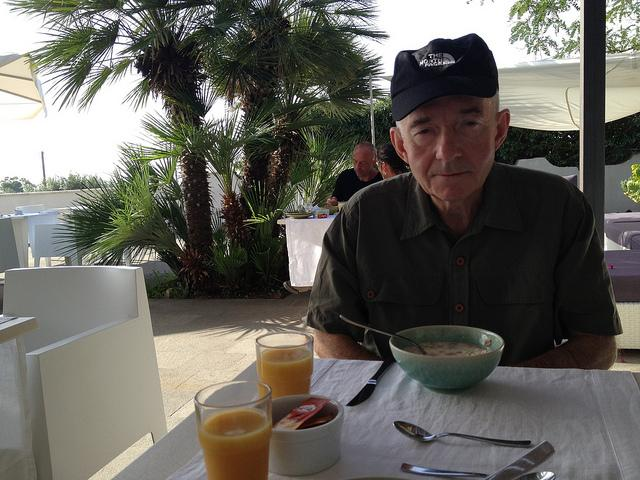What time of day does this man dine here? morning 